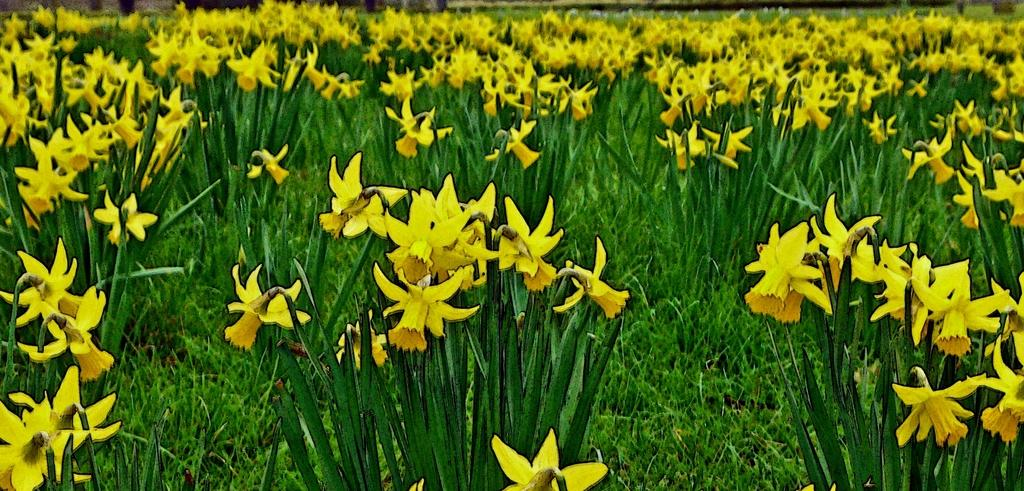What type of flowers can be seen in the image? There are yellow color flowers in the image. What other types of plants are present in the image? There are plants in the image. What is the ground covered with in the image? Grass is visible in the image. Is there any part of the image that is not clear? Yes, a part of the image is blurred. Can you describe the haircut of the dinosaur in the image? There are no dinosaurs present in the image, so it is not possible to describe their haircuts. 